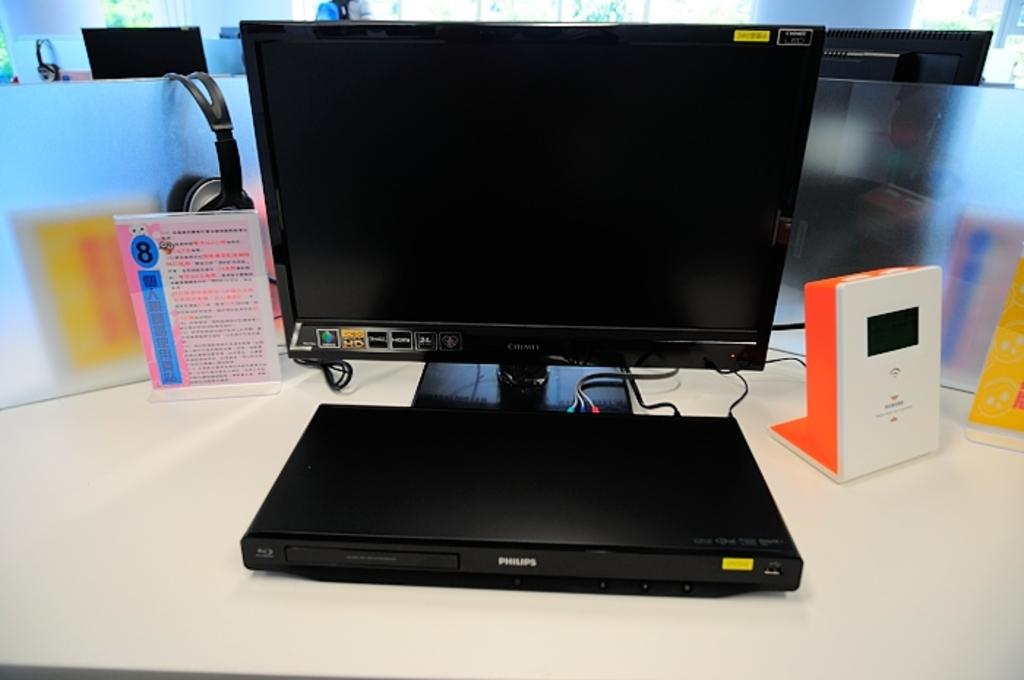<image>
Provide a brief description of the given image. A sticker on a computer monitor displays its HD capability. 